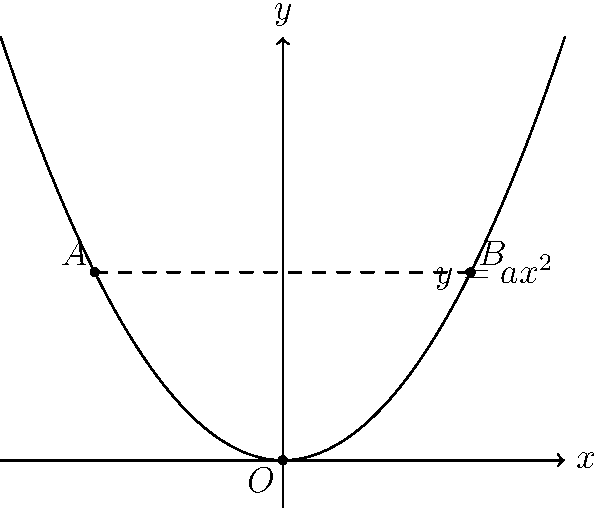As a professional videographer, you're planning a smooth panning shot along a parabolic path for a reenactment video. The camera's position is given by the function $y = ax^2$, where $a > 0$. You want to move the camera from point $A(-4, 16a)$ to point $B(4, 16a)$ in 10 seconds with constant speed along the curve. Find the optimal value of $a$ that minimizes the total distance traveled along the parabolic path. To solve this optimization problem, we'll follow these steps:

1) The arc length formula for a curve $y = f(x)$ from $x = a$ to $x = b$ is:

   $$L = \int_{a}^{b} \sqrt{1 + [f'(x)]^2} dx$$

2) In our case, $f(x) = ax^2$, so $f'(x) = 2ax$. We need to integrate from $x = -4$ to $x = 4$:

   $$L = \int_{-4}^{4} \sqrt{1 + (2ax)^2} dx$$

3) Substituting $u = 2ax$, $du = 2a dx$, and changing the limits:

   $$L = \frac{1}{2a} \int_{-8a}^{8a} \sqrt{1 + u^2} du$$

4) This integral results in:

   $$L = \frac{1}{2a} \left[ \frac{u}{2}\sqrt{1+u^2} + \frac{1}{2}\ln(u + \sqrt{1+u^2}) \right]_{-8a}^{8a}$$

5) Simplifying:

   $$L = \frac{1}{2a} \left[ 4a\sqrt{1+64a^2} + \frac{1}{2}\ln(8a + \sqrt{1+64a^2}) - \left(-4a\sqrt{1+64a^2} + \frac{1}{2}\ln(-8a + \sqrt{1+64a^2})\right) \right]$$

6) Further simplification leads to:

   $$L = 4\sqrt{1+64a^2} + \frac{1}{2a}\ln\left(8a + \sqrt{1+64a^2}\right)$$

7) To minimize L, we need to find where $\frac{dL}{da} = 0$. However, this equation is complex and difficult to solve analytically.

8) Instead, we can use the fact that the camera moves with constant speed along the curve. The speed is $v = \frac{L}{10}$ (as it takes 10 seconds).

9) The horizontal distance covered is 8 units (from -4 to 4). If we approximate the path as a straight line, the speed would be $v_{approx} = \frac{8}{10} = 0.8$ units/second.

10) Equating these:

    $$\frac{L}{10} = 0.8$$
    $$L = 8$$

11) Substituting this into the equation from step 6:

    $$8 = 4\sqrt{1+64a^2} + \frac{1}{2a}\ln\left(8a + \sqrt{1+64a^2}\right)$$

12) Solving this equation numerically (as it's transcendental), we get:

    $$a \approx 0.0625$$

This value of $a$ minimizes the total distance traveled while maintaining a constant speed along the curve.
Answer: $a \approx 0.0625$ 